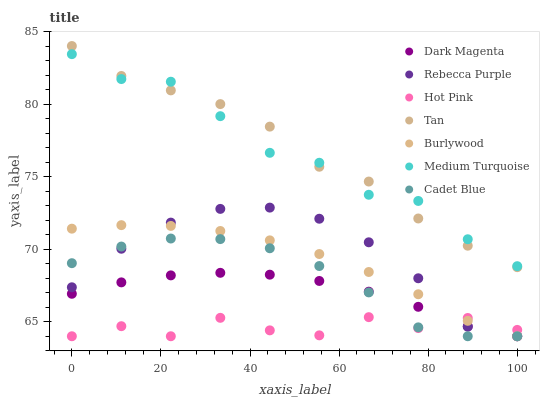Does Hot Pink have the minimum area under the curve?
Answer yes or no. Yes. Does Tan have the maximum area under the curve?
Answer yes or no. Yes. Does Dark Magenta have the minimum area under the curve?
Answer yes or no. No. Does Dark Magenta have the maximum area under the curve?
Answer yes or no. No. Is Dark Magenta the smoothest?
Answer yes or no. Yes. Is Hot Pink the roughest?
Answer yes or no. Yes. Is Burlywood the smoothest?
Answer yes or no. No. Is Burlywood the roughest?
Answer yes or no. No. Does Cadet Blue have the lowest value?
Answer yes or no. Yes. Does Medium Turquoise have the lowest value?
Answer yes or no. No. Does Tan have the highest value?
Answer yes or no. Yes. Does Dark Magenta have the highest value?
Answer yes or no. No. Is Hot Pink less than Tan?
Answer yes or no. Yes. Is Tan greater than Rebecca Purple?
Answer yes or no. Yes. Does Cadet Blue intersect Rebecca Purple?
Answer yes or no. Yes. Is Cadet Blue less than Rebecca Purple?
Answer yes or no. No. Is Cadet Blue greater than Rebecca Purple?
Answer yes or no. No. Does Hot Pink intersect Tan?
Answer yes or no. No. 